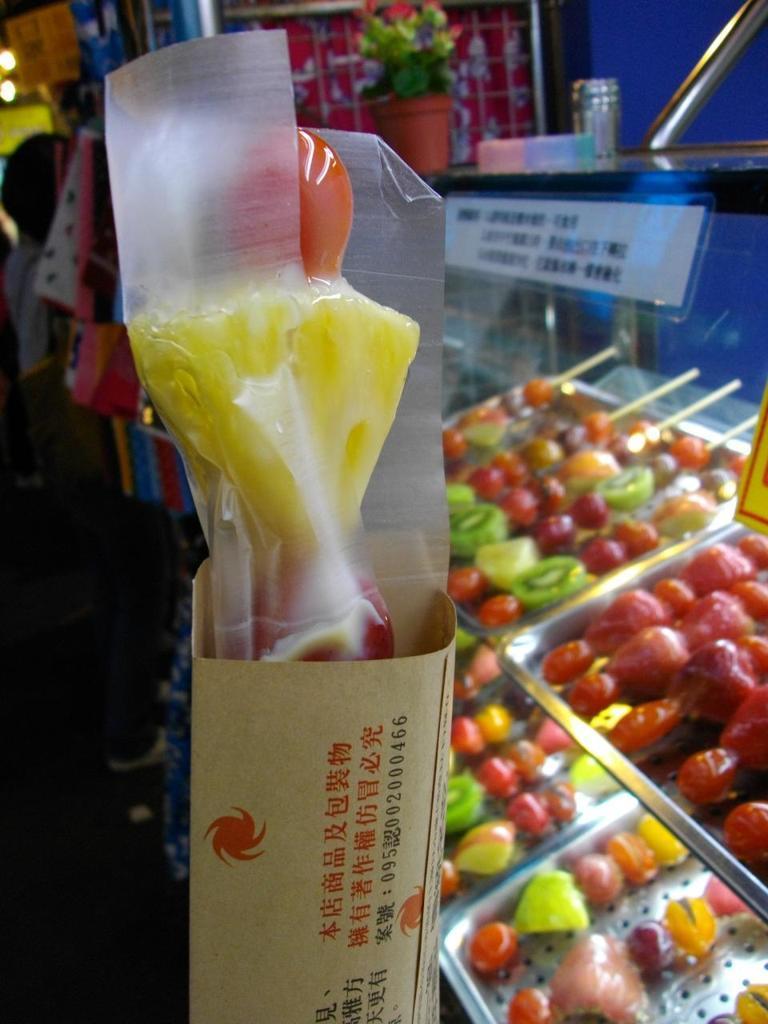Please provide a concise description of this image. In this image there are fruits on the trays inside a glass cupboard. There is a paper sticked on the cupboard. On the rack there is a houseplant. In the foreground there are fruits placed in a box. 